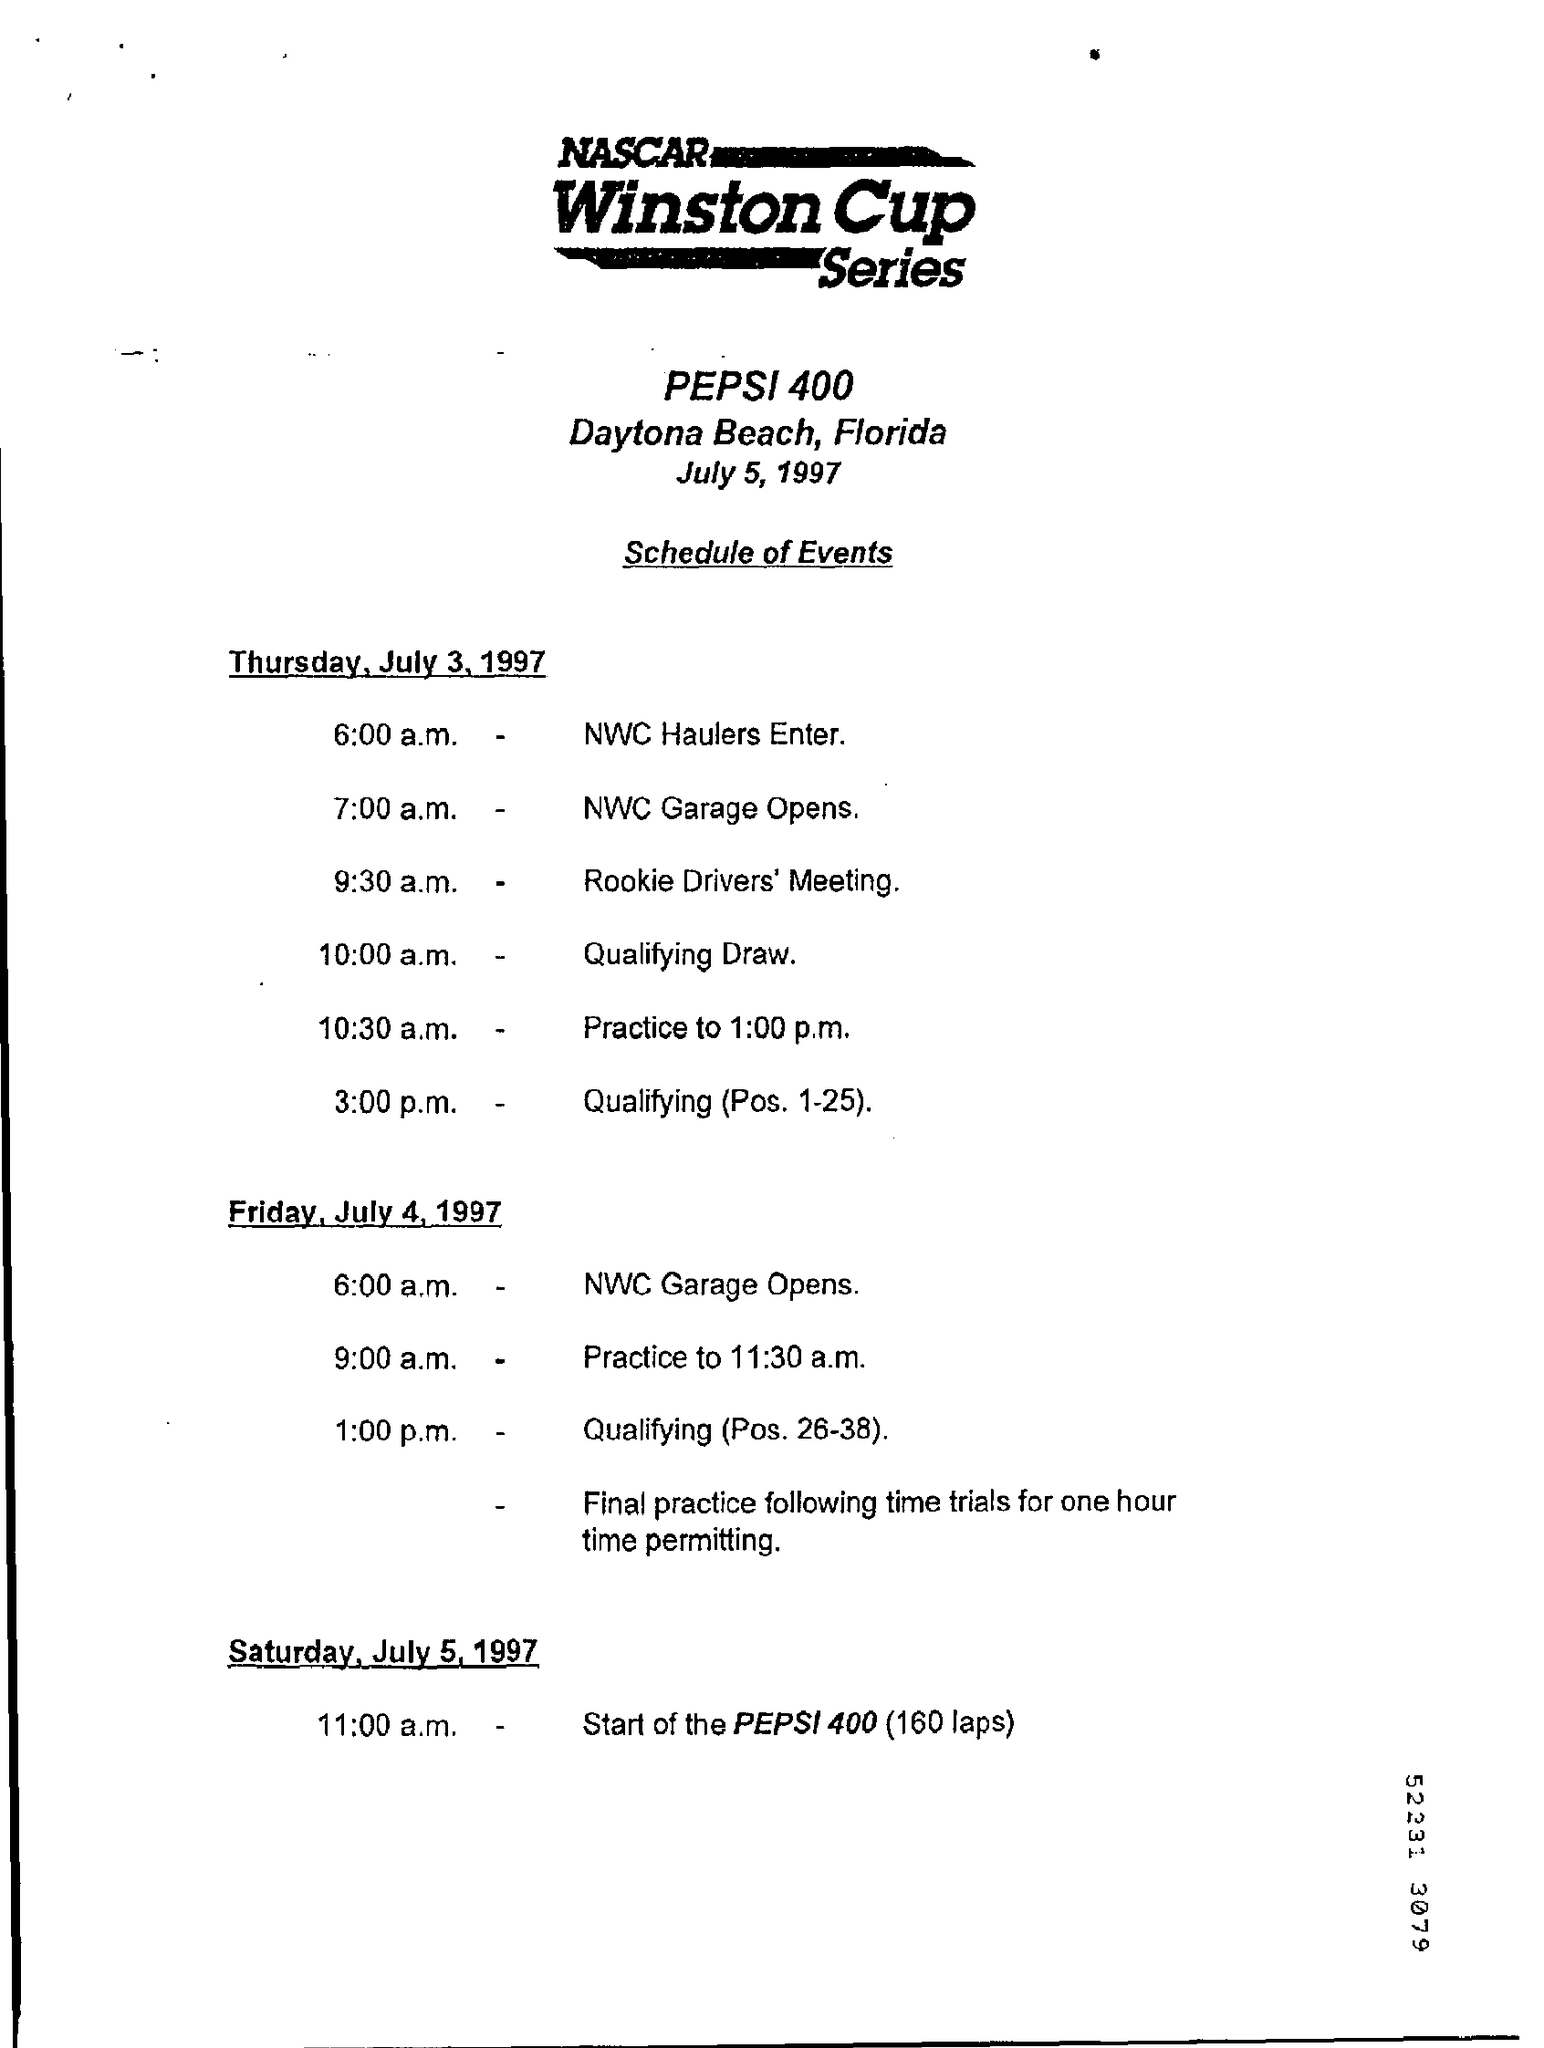What is the name of the series ?
Your response must be concise. Nascar Winston Cup series. What is the name of the state mentioned ?
Your response must be concise. Florida. What is the time for the rookie driver's meeting ?
Ensure brevity in your answer.  9:30 a.m. What is the day on july 5, 1997
Keep it short and to the point. Saturday. 